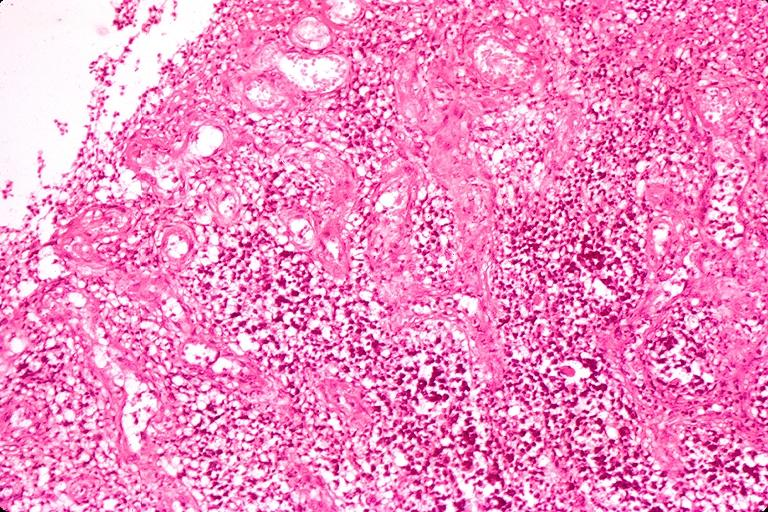where is this?
Answer the question using a single word or phrase. Oral 